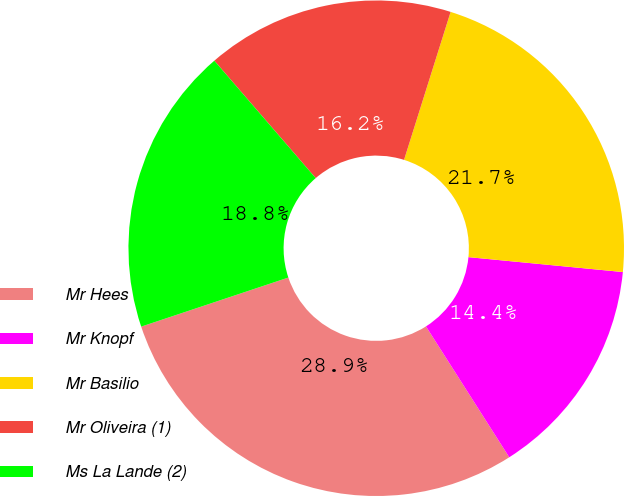Convert chart. <chart><loc_0><loc_0><loc_500><loc_500><pie_chart><fcel>Mr Hees<fcel>Mr Knopf<fcel>Mr Basilio<fcel>Mr Oliveira (1)<fcel>Ms La Lande (2)<nl><fcel>28.9%<fcel>14.45%<fcel>21.68%<fcel>16.19%<fcel>18.79%<nl></chart> 